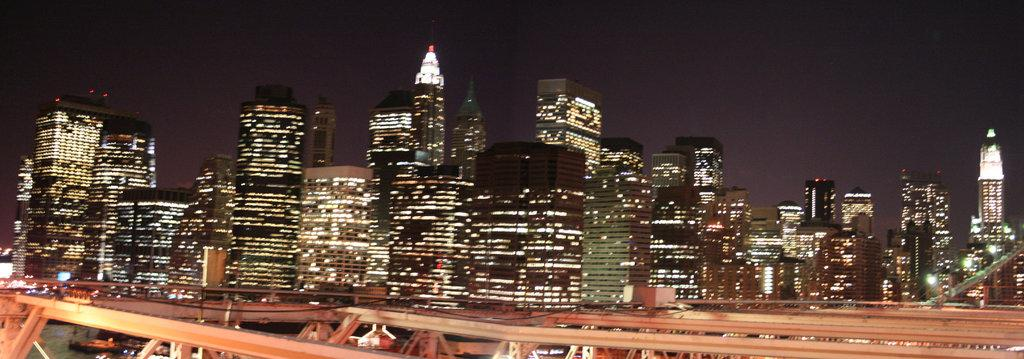What type of location is shown in the image? The image depicts a city. What are some characteristics of the city? There are tall buildings in the city. When was the image captured? The image was captured at night. How do the buildings appear in the nighttime image? The buildings are colorful in the nighttime image. What type of badge is being worn by the building in the image? There is no badge present in the image, as the subject is a city with buildings. What feeling does the image evoke in the viewer? The image itself does not evoke a specific feeling, as it is an objective representation of a city at night. 